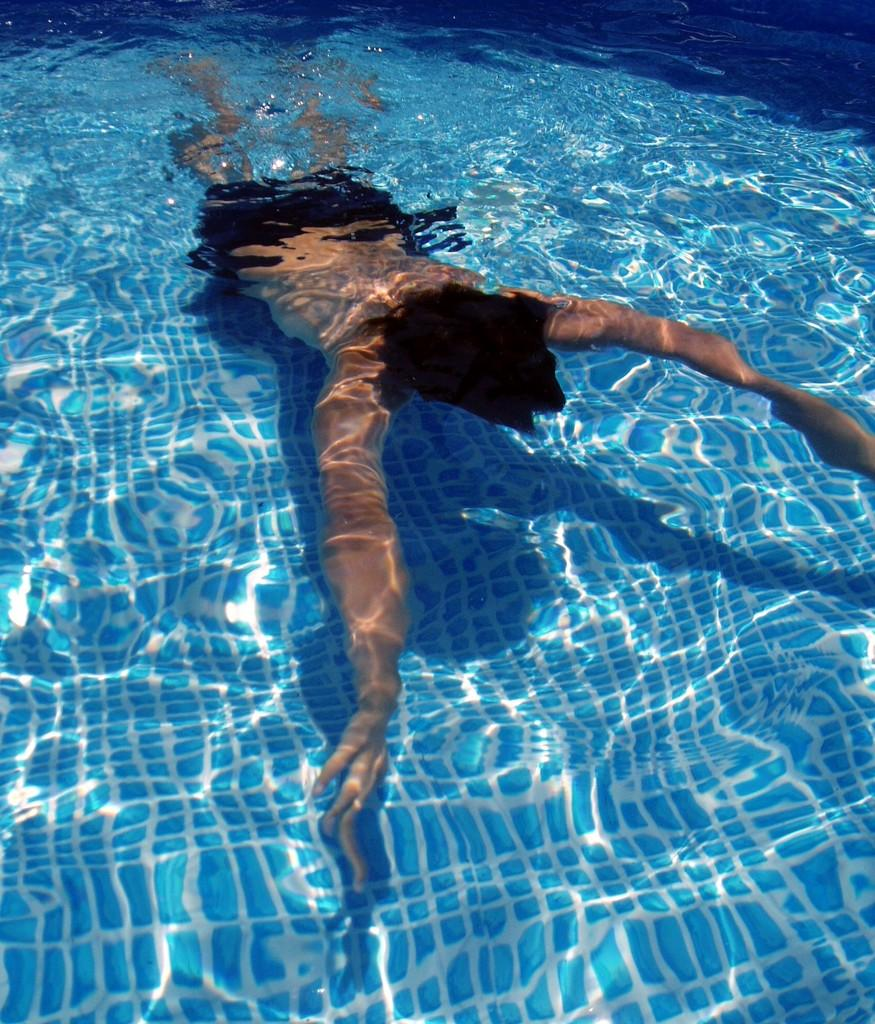What is the main feature of the image? There is a swimming pool in the picture. What is the person in the image doing? A person is swimming in the pool. What can be seen on the bottom of the pool? The bottom of the pool has blue tiles. What type of pencil can be seen floating on the surface of the pool? There is no pencil present in the image; it only features a swimming pool and a person swimming. 